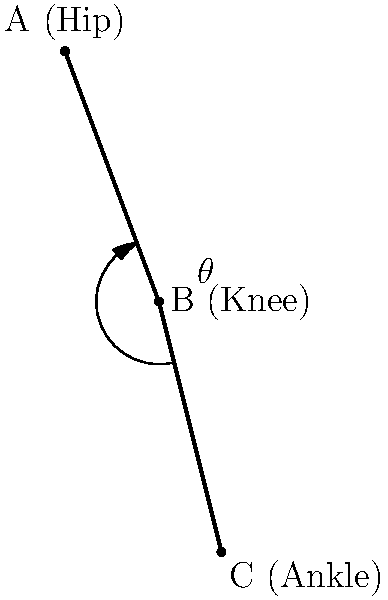Given the stick figure diagram representing a human leg during the gait cycle, calculate the knee joint angle $\theta$ in degrees. Use the coordinates of the hip (A), knee (B), and ankle (C) joints: A(0,0), B(30,-80), and C(50,-160). To calculate the knee joint angle $\theta$, we'll use the law of cosines. Here's the step-by-step process:

1) First, calculate the lengths of the three sides of the triangle formed by the hip, knee, and ankle:

   AB = $\sqrt{(30-0)^2 + (-80-0)^2} = \sqrt{900 + 6400} = \sqrt{7300} \approx 85.44$
   BC = $\sqrt{(50-30)^2 + (-160+80)^2} = \sqrt{400 + 6400} = \sqrt{6800} \approx 82.46$
   AC = $\sqrt{(50-0)^2 + (-160-0)^2} = \sqrt{2500 + 25600} = \sqrt{28100} \approx 167.63$

2) Now, use the law of cosines to find the angle $\theta$:

   $AC^2 = AB^2 + BC^2 - 2(AB)(BC)\cos(\theta)$

3) Substitute the values:

   $167.63^2 = 85.44^2 + 82.46^2 - 2(85.44)(82.46)\cos(\theta)$

4) Simplify:

   $28099.61 = 7300.00 + 6799.65 - 14095.71\cos(\theta)$

5) Solve for $\cos(\theta)$:

   $14095.71\cos(\theta) = 7300.00 + 6799.65 - 28099.61$
   $14095.71\cos(\theta) = -13999.96$
   $\cos(\theta) = -0.9932$

6) Take the inverse cosine (arccos) of both sides:

   $\theta = \arccos(-0.9932)$

7) Convert to degrees:

   $\theta = 168.37°$
Answer: $168.37°$ 